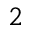Convert formula to latex. <formula><loc_0><loc_0><loc_500><loc_500>2</formula> 